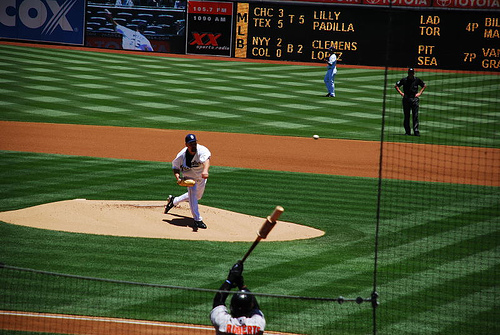Can you describe what's happening in this baseball game? In the image, we see a baseball pitcher in the middle of a pitch, with intense focus and proper form as he delivers the ball toward the batter. The batter is awaiting the pitch in a stance that suggests he's ready to swing. The atmosphere seems charged with excitement typical of a professional baseball game. What team might the pitcher belong to, based on his uniform? Since the image doesn't provide clear details on the uniform, it's difficult to determine accurately which team the pitcher belongs to. However, with the information typically available, one might identify the team by the colors, logos, and patterns depicted on his jersey and hat, assuming they were visible. 